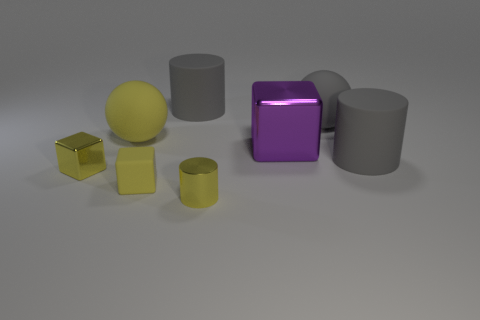Subtract all large blocks. How many blocks are left? 2 Add 2 yellow cubes. How many objects exist? 10 Subtract all purple blocks. How many blocks are left? 2 Subtract all blocks. How many objects are left? 5 Subtract all gray cylinders. Subtract all cyan cubes. How many cylinders are left? 1 Subtract all red balls. How many gray cylinders are left? 2 Subtract all metallic objects. Subtract all small purple matte balls. How many objects are left? 5 Add 1 small metallic cubes. How many small metallic cubes are left? 2 Add 1 large purple things. How many large purple things exist? 2 Subtract 2 gray cylinders. How many objects are left? 6 